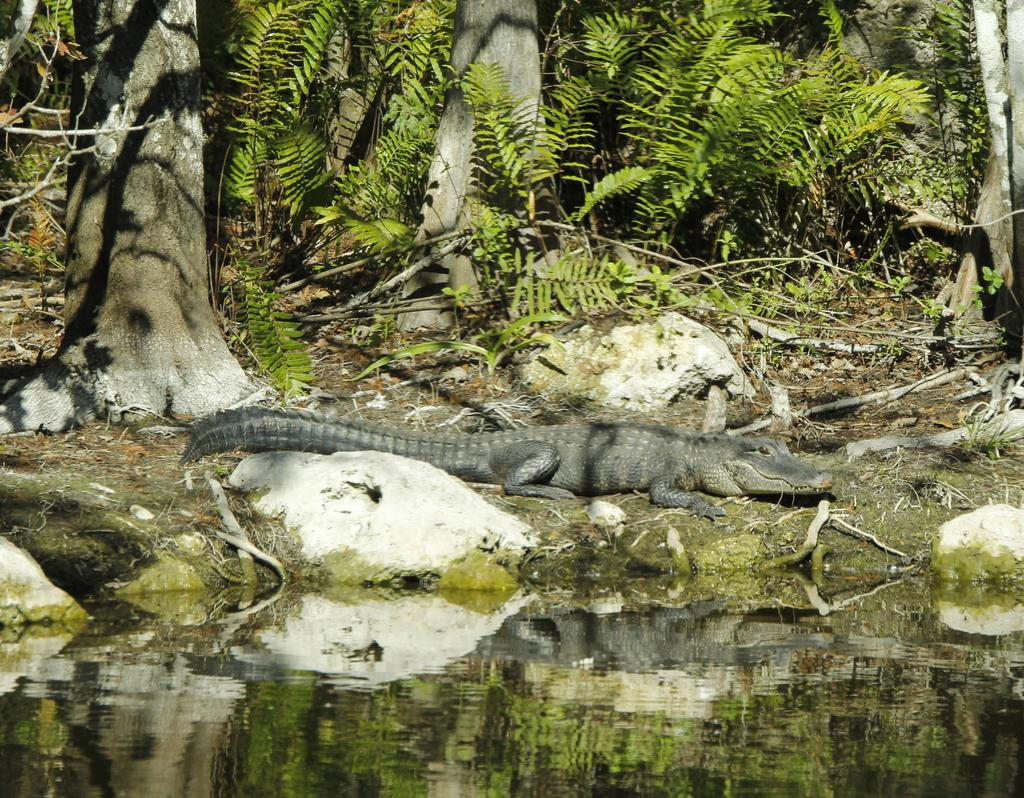What is the primary element present in the image? There is water in the image. What type of animal can be seen on the ground in the image? There is a crocodile on the ground in the image. What type of vegetation is visible in the image? There are trees visible in the image. What type of payment method is accepted by the coach in the image? There is no coach present in the image, so it is not possible to determine what payment method might be accepted. 